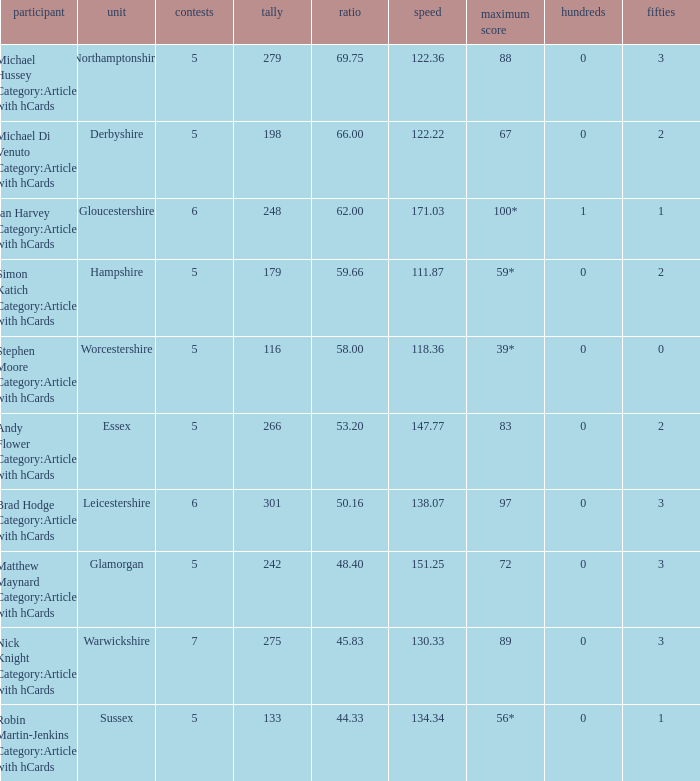What is the team Sussex' highest score? 56*. 